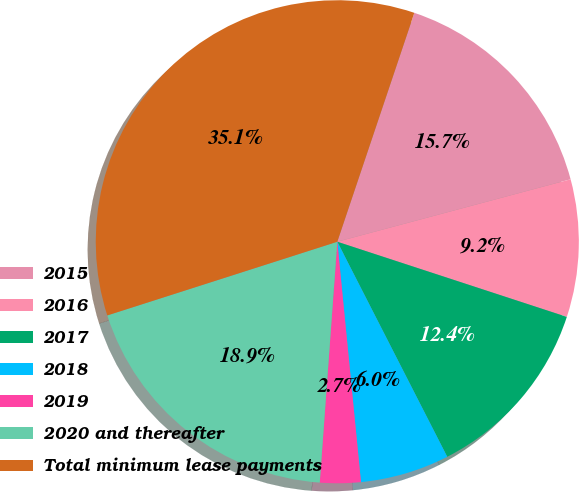Convert chart. <chart><loc_0><loc_0><loc_500><loc_500><pie_chart><fcel>2015<fcel>2016<fcel>2017<fcel>2018<fcel>2019<fcel>2020 and thereafter<fcel>Total minimum lease payments<nl><fcel>15.67%<fcel>9.2%<fcel>12.44%<fcel>5.96%<fcel>2.72%<fcel>18.91%<fcel>35.1%<nl></chart> 